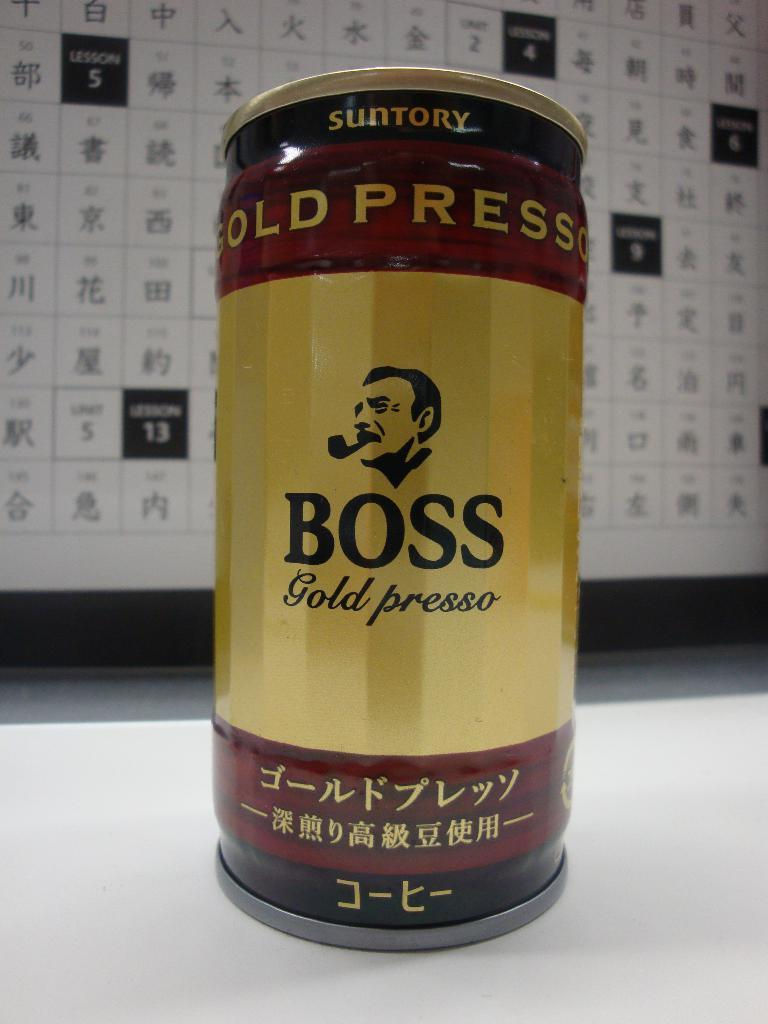<image>
Summarize the visual content of the image. A can of BOSS gold presso with the image of a man's head smoking a pipe. 